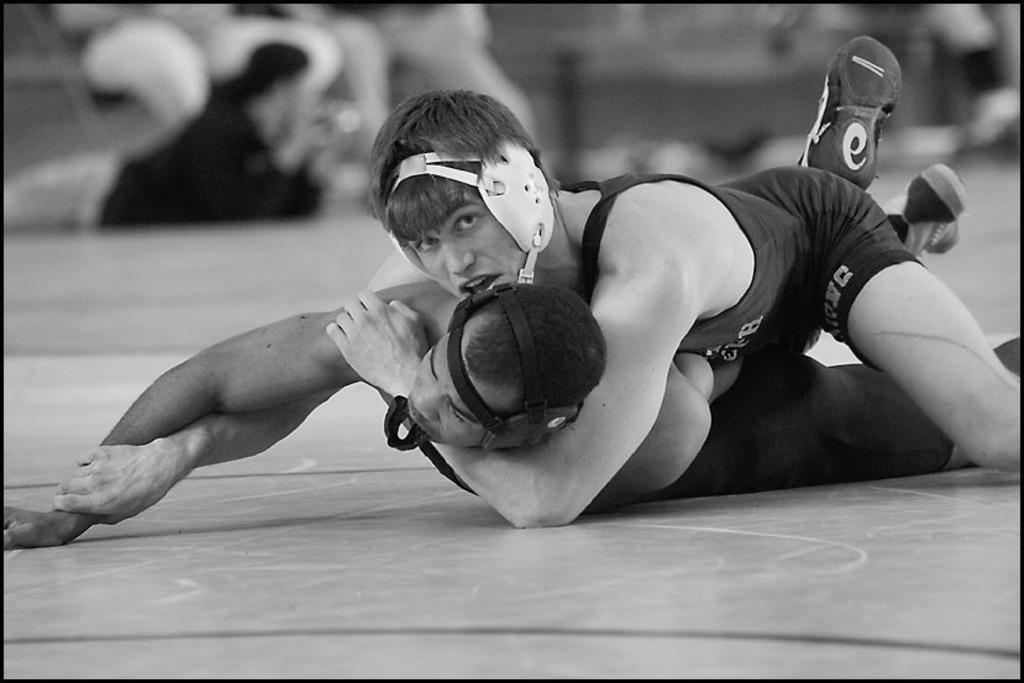What are the two persons in the center of the image doing? The two persons are wrestling in the center of the image. On what surface is the wrestling taking place? The wrestling is taking place on the ground. Can you describe the people visible in the background of the image? There are persons visible in the background of the image, but their specific actions or characteristics are not mentioned in the provided facts. What type of bomb can be seen in the frame of the image? There is no bomb present in the image. Can you describe the squirrel that is climbing the tree in the image? There is no squirrel or tree present in the image; it features two persons wrestling on the ground. 